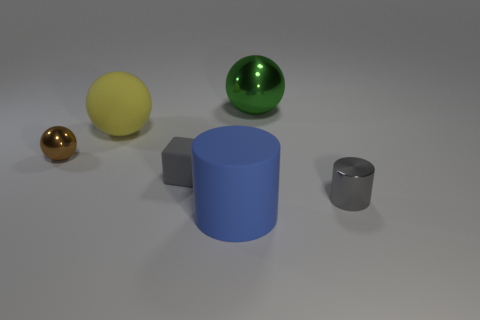What number of blue rubber objects have the same size as the yellow object?
Your answer should be compact. 1. What number of metal objects are in front of the sphere right of the rubber thing behind the small brown sphere?
Give a very brief answer. 2. How many big things are both behind the big matte sphere and in front of the small rubber object?
Ensure brevity in your answer.  0. Are there any other things that are the same color as the big rubber ball?
Make the answer very short. No. How many rubber things are gray objects or large blue cylinders?
Your answer should be very brief. 2. There is a large object that is left of the large matte object in front of the small thing that is on the right side of the large cylinder; what is it made of?
Make the answer very short. Rubber. What is the material of the large thing in front of the tiny metal object on the left side of the large matte ball?
Give a very brief answer. Rubber. There is a metallic ball that is behind the large rubber sphere; is its size the same as the blue cylinder to the right of the big yellow ball?
Your answer should be compact. Yes. What number of small things are green shiny objects or yellow matte things?
Your answer should be very brief. 0. What number of objects are either metal things that are in front of the small ball or big cylinders?
Offer a terse response. 2. 